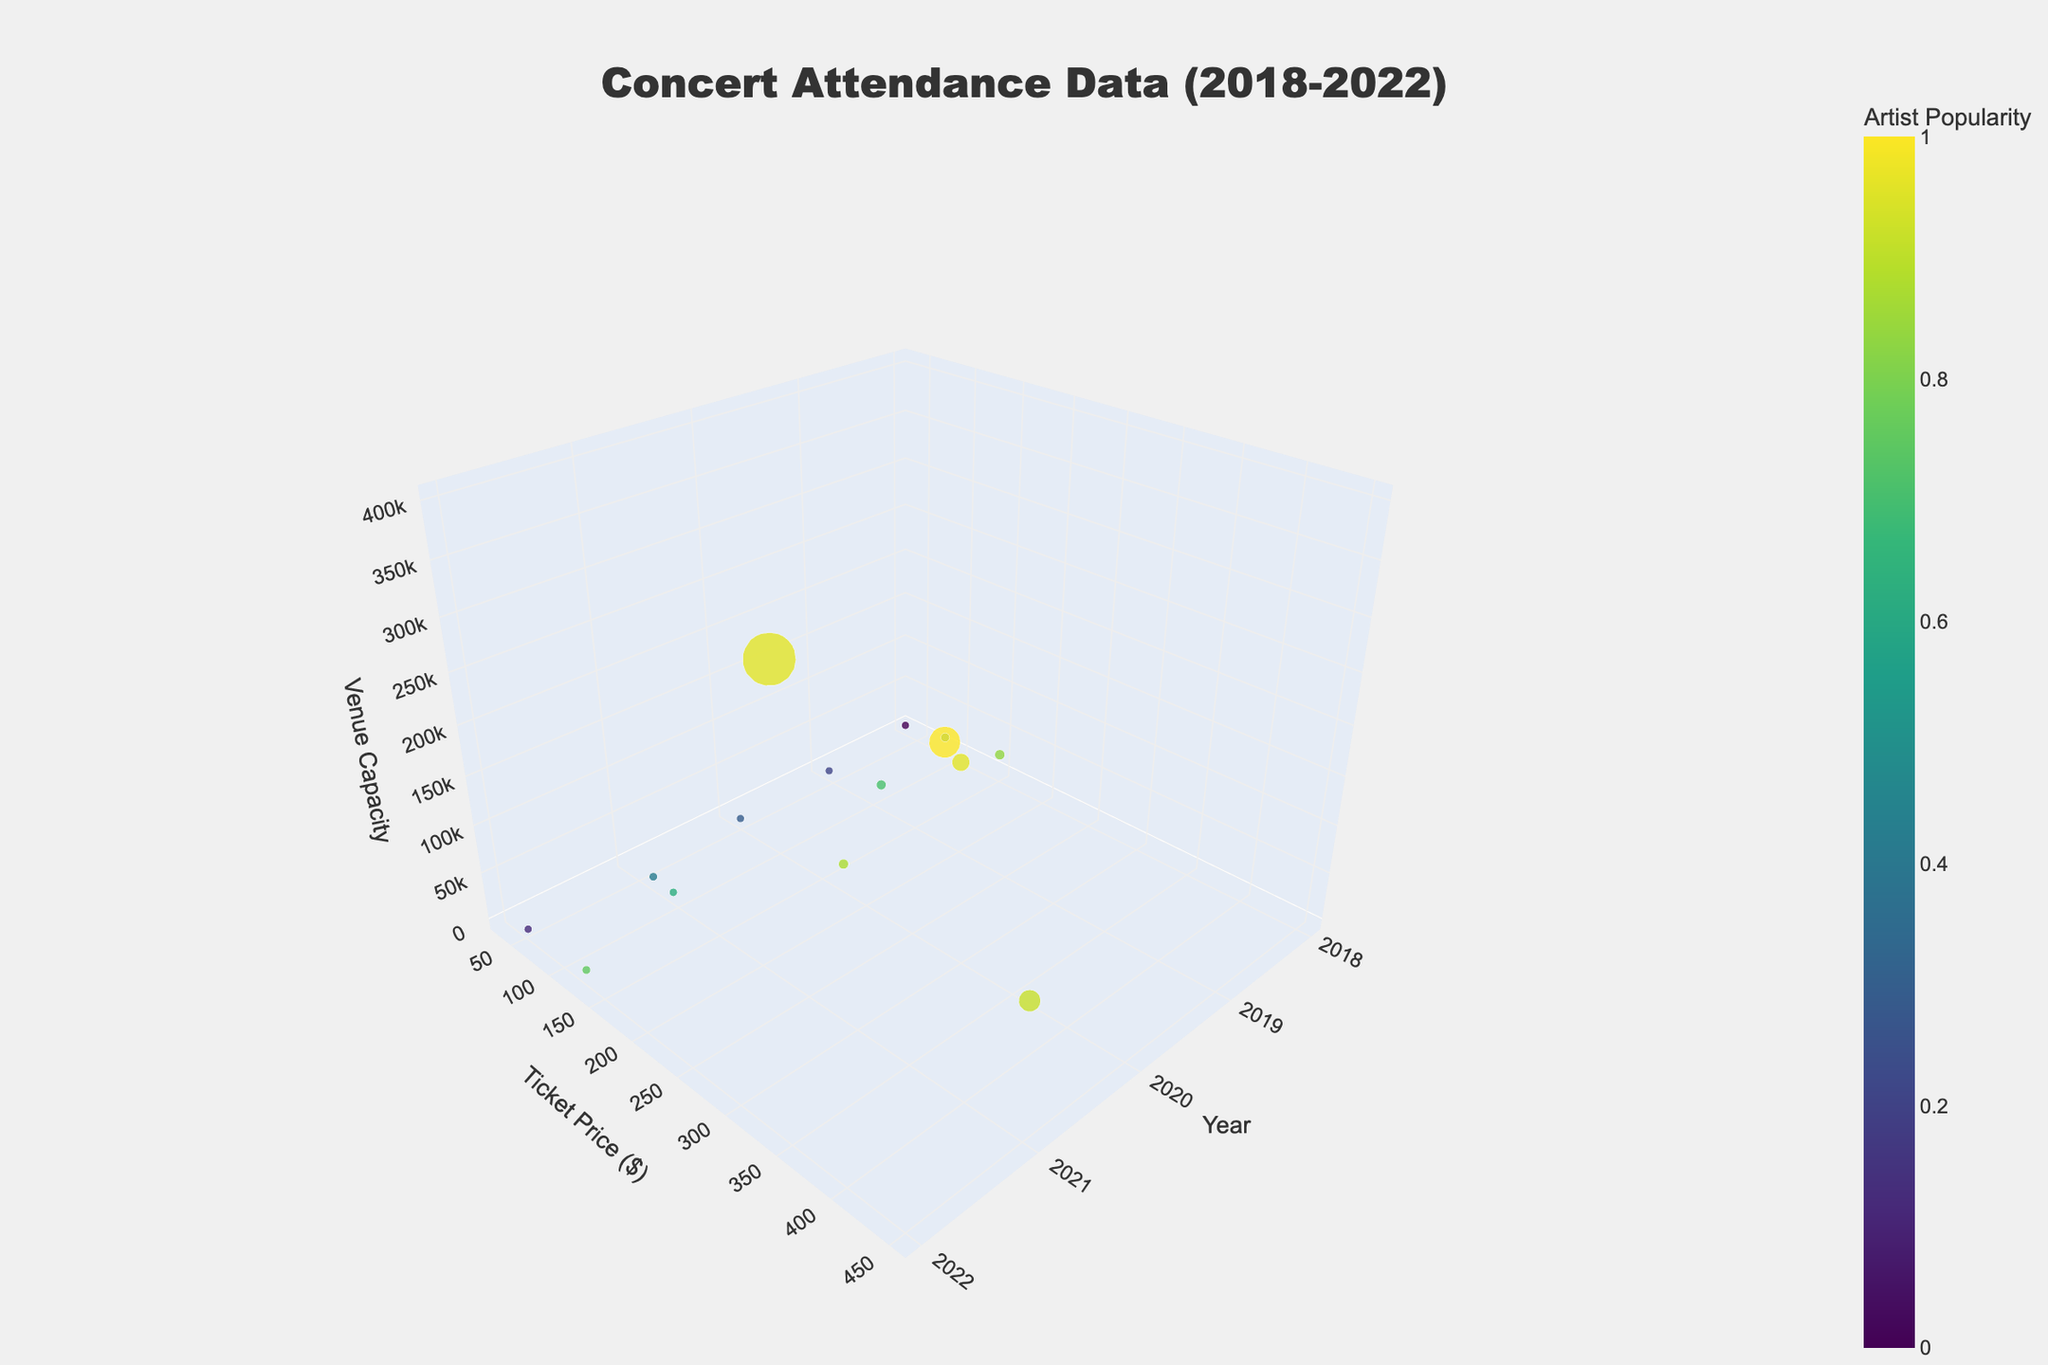What's the title of the plot? The title is located at the top center of the plot and is typically formatted in a larger font for prominence.
Answer: Concert Attendance Data (2018-2022) How many different years are covered in the plot? By looking at the x-axis labeled 'Year,' which has tick marks and labels, you can count the distinct years represented.
Answer: 5 Which data point corresponds to the highest ticket price? By observing the y-axis labeled 'Ticket Price ($),' identify the point at the highest numerical value.
Answer: Coachella Festival in 2021 What's the relationship between artist popularity and color on the plot? The color bar on the side of the plot indicates that the colors vary with artist popularity, from lower popularity in darker shades to higher popularity in lighter shades.
Answer: Higher artist popularity is shown in lighter colors Which venue had the largest capacity and what year was it? By examining the z-axis labeled 'Venue Capacity,' find the largest visible data point and check its corresponding x (Year) and text (Venue) label.
Answer: Glastonbury Festival, 2020 What is the overall trend in ticket prices over the years? By looking along the y-axis (Ticket Price) and observing the general spread and inclination of data points across different years along the x-axis.
Answer: Ticket prices generally increased over the years Identify the venue with the smallest capacity and its ticket price. By finding the smallest z-axis value (Venue Capacity) on the plot and checking the corresponding y-axis value (Ticket Price).
Answer: The Troubadour, $35 How does the attendance relate to the marker size in the plot? The marker size is scaled according to Attendance, with larger markers representing higher attendance.
Answer: Larger markers represent higher attendance Which year recorded the highest overall attendance, considering the marker sizes? By analyzing marker sizes over all years on the x-axis, the year with the largest average marker sizes indicates the highest attendance.
Answer: 2022 Compare the ticket price for the highest capacity venue with the ticket price for the lowest capacity venue. By noting the ticket prices for Glastonbury Festival (highest capacity) and The Troubadour (lowest capacity) from the y-axis and performing a comparison.
Answer: $280 (highest capacity, Glastonbury Fest.) vs. $35 (lowest capacity, The Troubadour) 